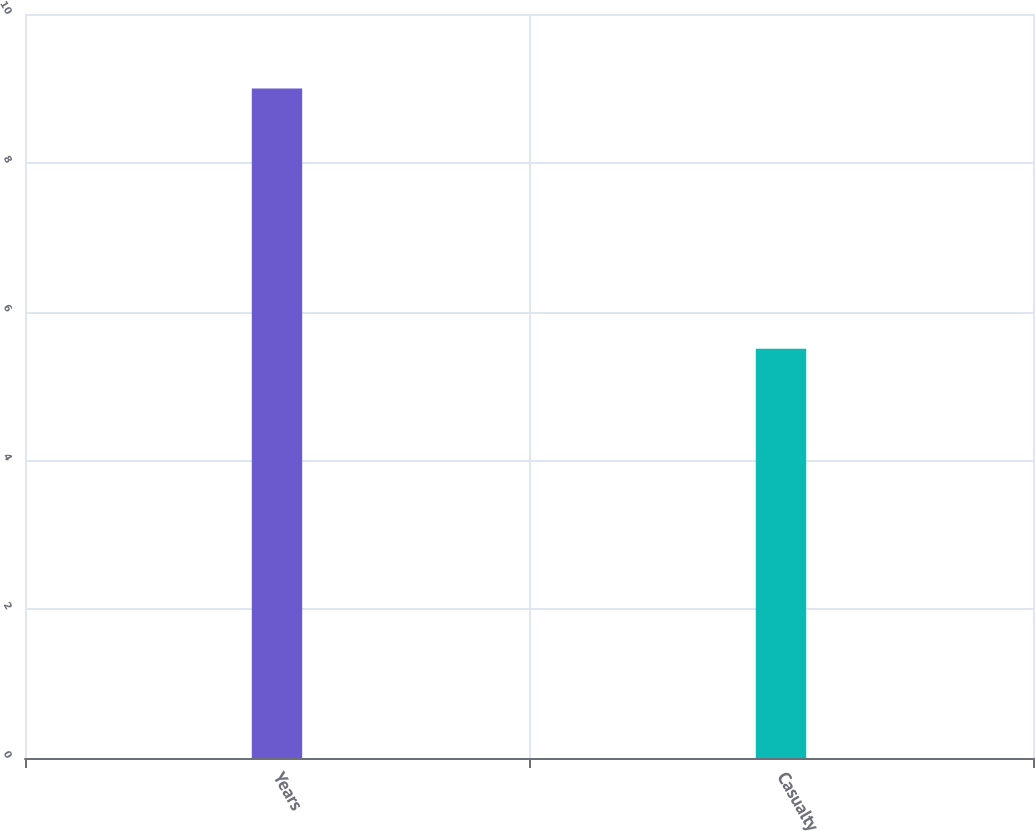<chart> <loc_0><loc_0><loc_500><loc_500><bar_chart><fcel>Years<fcel>Casualty<nl><fcel>9<fcel>5.5<nl></chart> 